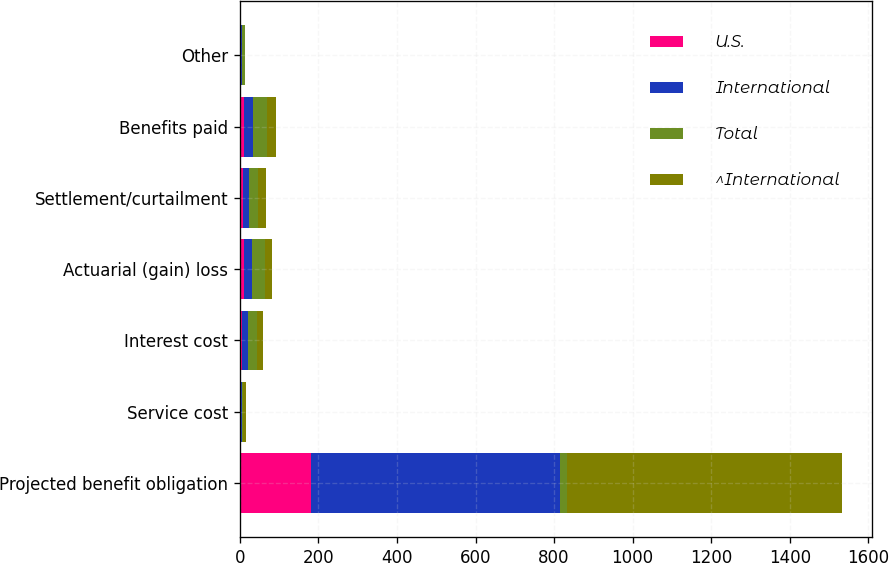<chart> <loc_0><loc_0><loc_500><loc_500><stacked_bar_chart><ecel><fcel>Projected benefit obligation<fcel>Service cost<fcel>Interest cost<fcel>Actuarial (gain) loss<fcel>Settlement/curtailment<fcel>Benefits paid<fcel>Other<nl><fcel>U.S.<fcel>182.1<fcel>0.1<fcel>6.5<fcel>10.6<fcel>7.6<fcel>11.2<fcel>0.2<nl><fcel>International<fcel>633.5<fcel>4.2<fcel>15.2<fcel>21.5<fcel>15.1<fcel>22.9<fcel>5.8<nl><fcel>Total<fcel>16.1<fcel>4.3<fcel>21.7<fcel>32.1<fcel>22.7<fcel>34.1<fcel>6<nl><fcel>^International<fcel>702.2<fcel>6.9<fcel>16.1<fcel>16.5<fcel>21.2<fcel>22.6<fcel>1.1<nl></chart> 